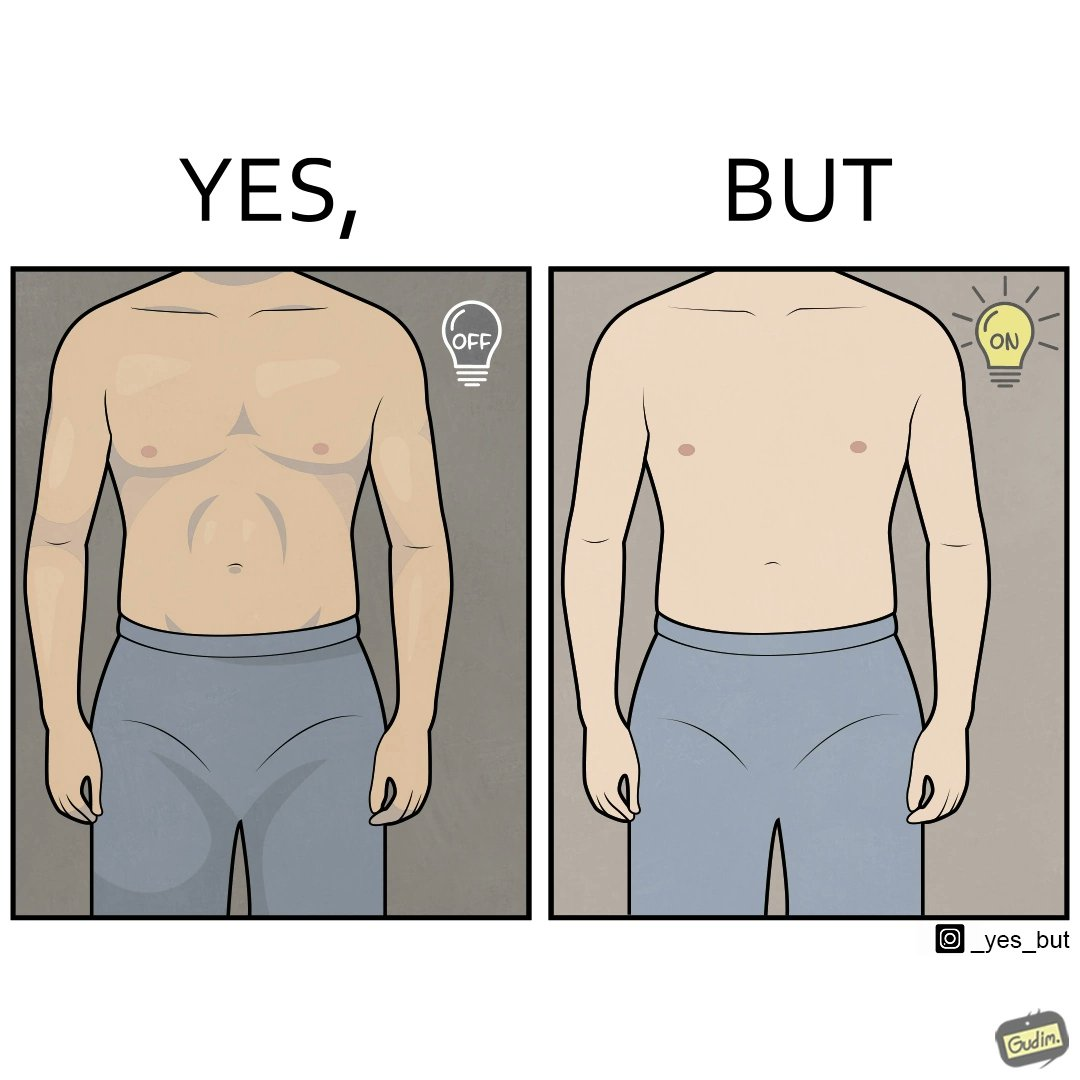Is this a satirical image? Yes, this image is satirical. 